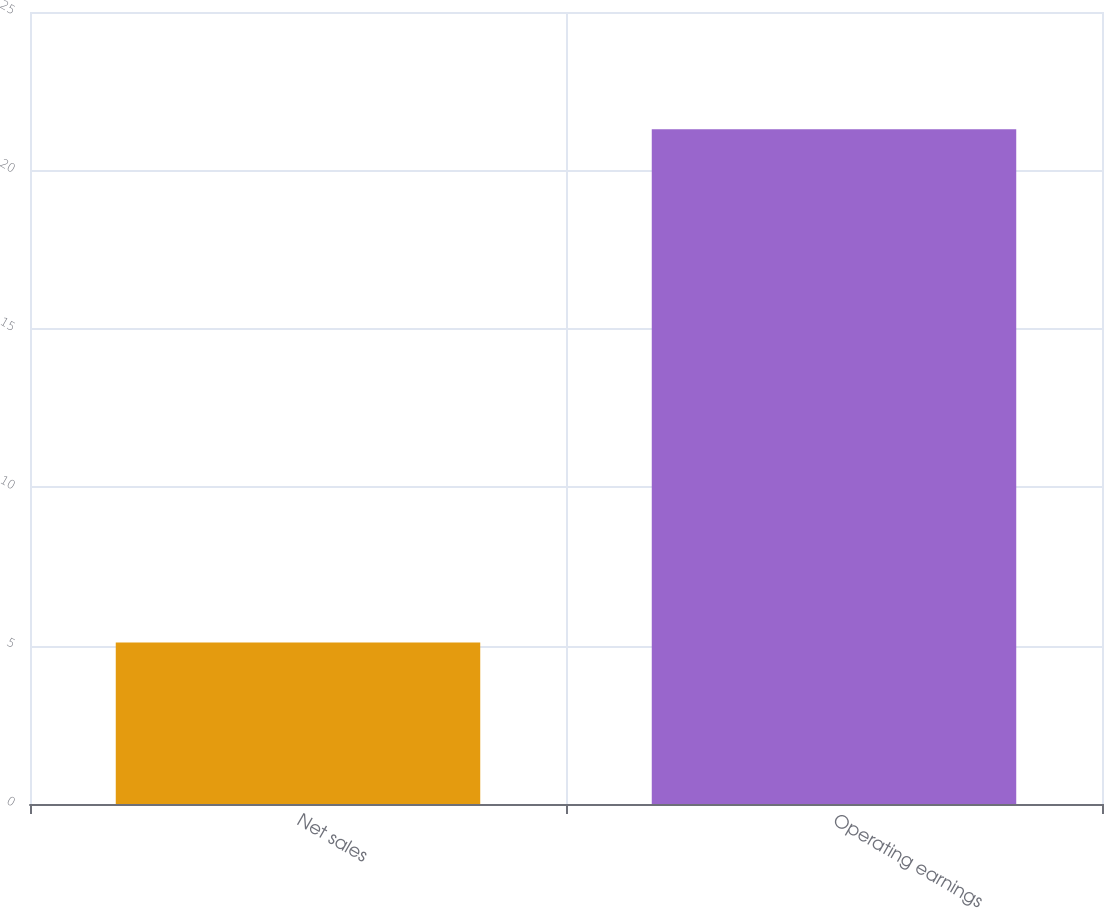Convert chart to OTSL. <chart><loc_0><loc_0><loc_500><loc_500><bar_chart><fcel>Net sales<fcel>Operating earnings<nl><fcel>5.1<fcel>21.3<nl></chart> 